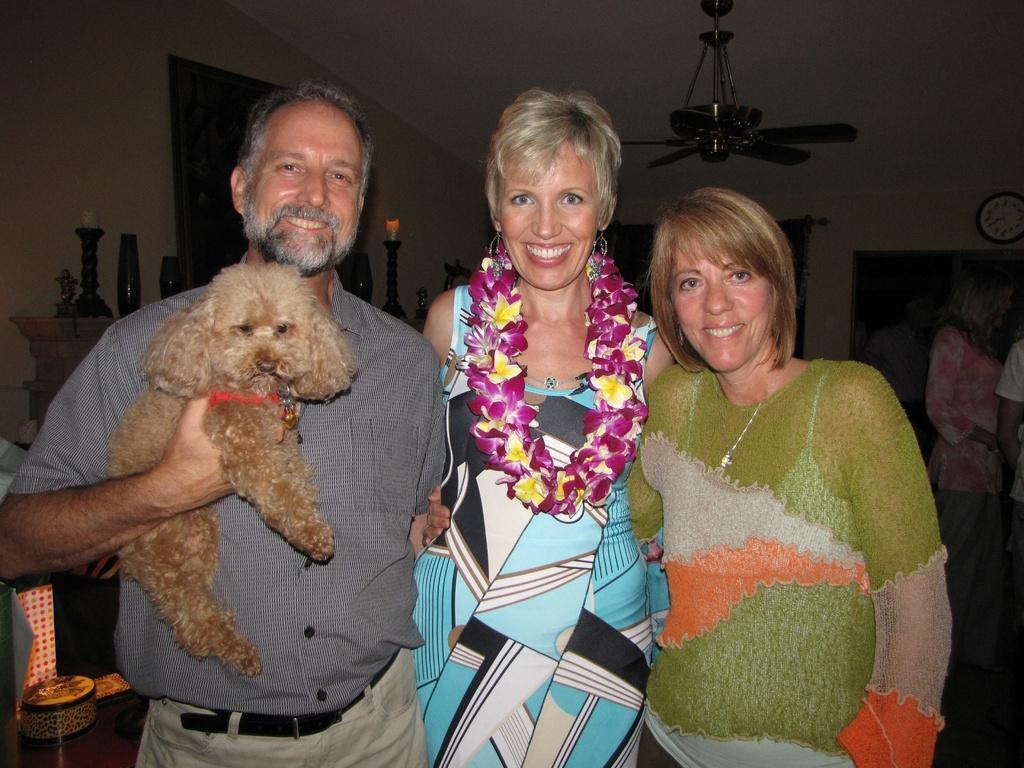How would you summarize this image in a sentence or two? In this picture I can see a man and 2 women and I see that they're standing and smiling and I see the man is holding a dog. In the background I see the wall, a fan on the ceiling, few things on the left side of this image, a clock on the right side of this image and I see few people. 